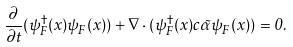<formula> <loc_0><loc_0><loc_500><loc_500>\frac { \partial } { \partial t } ( \psi _ { F } ^ { \dag } ( x ) \psi _ { F } ( x ) ) + \nabla \cdot ( \psi _ { F } ^ { \dag } ( x ) c \vec { \alpha } \psi _ { F } ( x ) ) = 0 .</formula> 